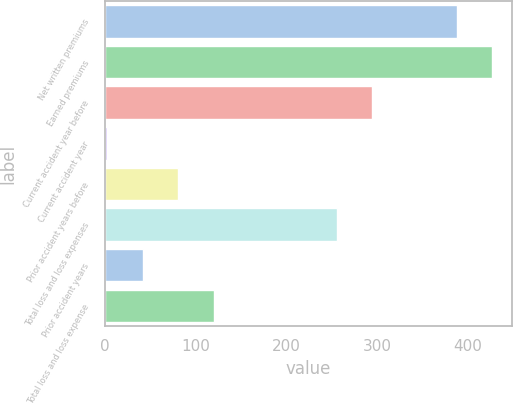<chart> <loc_0><loc_0><loc_500><loc_500><bar_chart><fcel>Net written premiums<fcel>Earned premiums<fcel>Current accident year before<fcel>Current accident year<fcel>Prior accident years before<fcel>Total loss and loss expenses<fcel>Prior accident years<fcel>Total loss and loss expense<nl><fcel>388<fcel>427.1<fcel>295.1<fcel>3<fcel>81.2<fcel>256<fcel>42.1<fcel>120.3<nl></chart> 